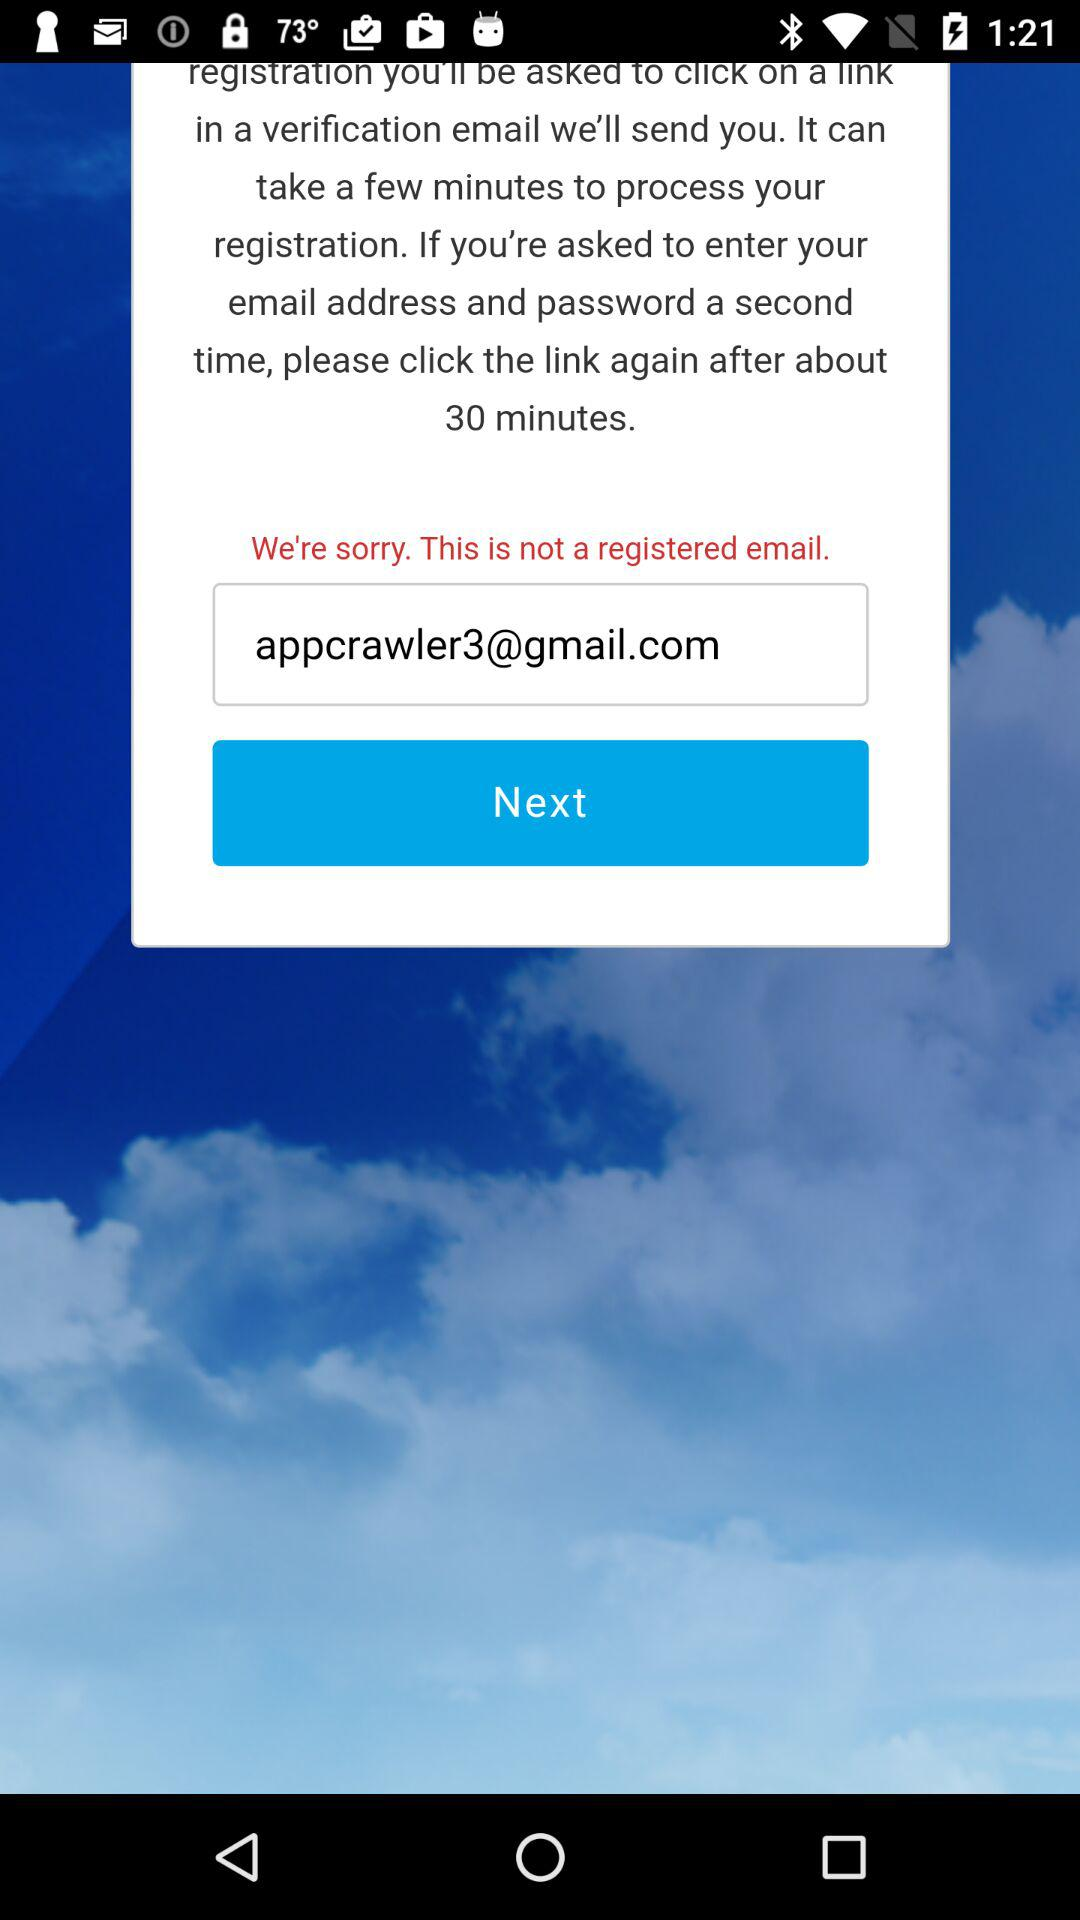What is the email address? The email address is appcrawler3@gmail.com. 